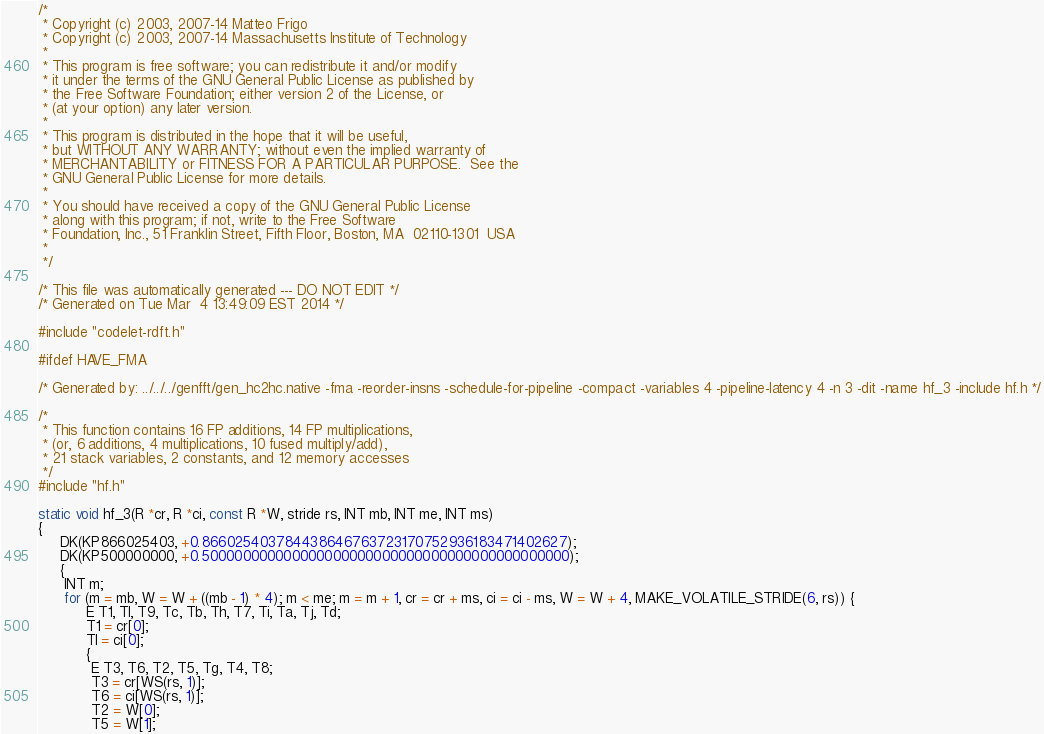Convert code to text. <code><loc_0><loc_0><loc_500><loc_500><_C_>/*
 * Copyright (c) 2003, 2007-14 Matteo Frigo
 * Copyright (c) 2003, 2007-14 Massachusetts Institute of Technology
 *
 * This program is free software; you can redistribute it and/or modify
 * it under the terms of the GNU General Public License as published by
 * the Free Software Foundation; either version 2 of the License, or
 * (at your option) any later version.
 *
 * This program is distributed in the hope that it will be useful,
 * but WITHOUT ANY WARRANTY; without even the implied warranty of
 * MERCHANTABILITY or FITNESS FOR A PARTICULAR PURPOSE.  See the
 * GNU General Public License for more details.
 *
 * You should have received a copy of the GNU General Public License
 * along with this program; if not, write to the Free Software
 * Foundation, Inc., 51 Franklin Street, Fifth Floor, Boston, MA  02110-1301  USA
 *
 */

/* This file was automatically generated --- DO NOT EDIT */
/* Generated on Tue Mar  4 13:49:09 EST 2014 */

#include "codelet-rdft.h"

#ifdef HAVE_FMA

/* Generated by: ../../../genfft/gen_hc2hc.native -fma -reorder-insns -schedule-for-pipeline -compact -variables 4 -pipeline-latency 4 -n 3 -dit -name hf_3 -include hf.h */

/*
 * This function contains 16 FP additions, 14 FP multiplications,
 * (or, 6 additions, 4 multiplications, 10 fused multiply/add),
 * 21 stack variables, 2 constants, and 12 memory accesses
 */
#include "hf.h"

static void hf_3(R *cr, R *ci, const R *W, stride rs, INT mb, INT me, INT ms)
{
     DK(KP866025403, +0.866025403784438646763723170752936183471402627);
     DK(KP500000000, +0.500000000000000000000000000000000000000000000);
     {
	  INT m;
	  for (m = mb, W = W + ((mb - 1) * 4); m < me; m = m + 1, cr = cr + ms, ci = ci - ms, W = W + 4, MAKE_VOLATILE_STRIDE(6, rs)) {
	       E T1, Tl, T9, Tc, Tb, Th, T7, Ti, Ta, Tj, Td;
	       T1 = cr[0];
	       Tl = ci[0];
	       {
		    E T3, T6, T2, T5, Tg, T4, T8;
		    T3 = cr[WS(rs, 1)];
		    T6 = ci[WS(rs, 1)];
		    T2 = W[0];
		    T5 = W[1];</code> 